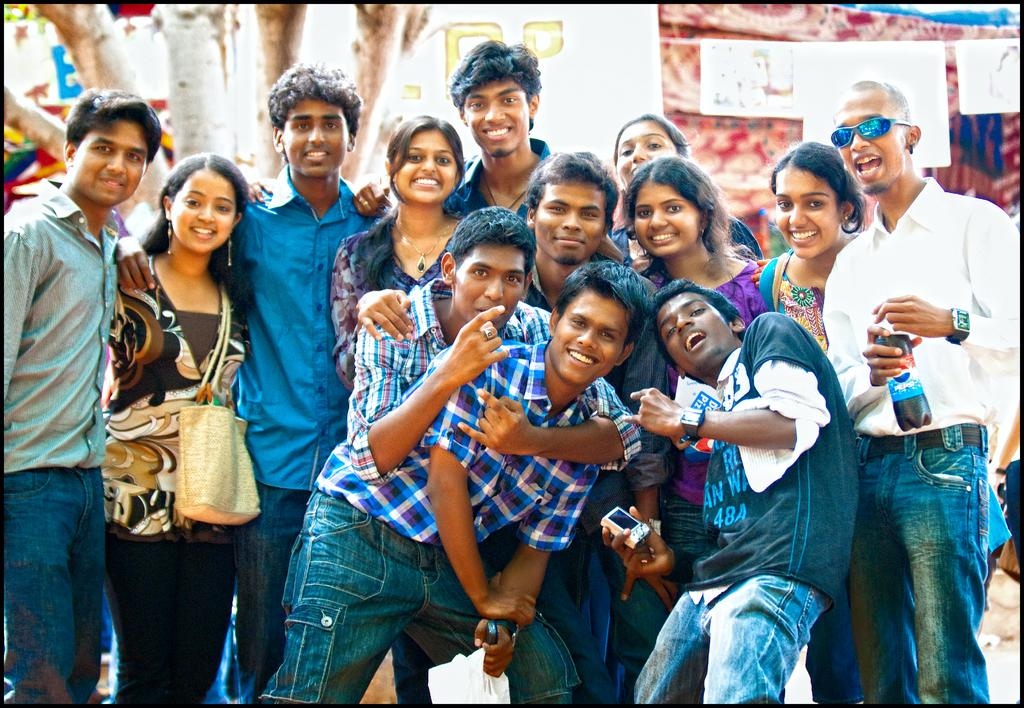How many people are in the image? There is a group of people in the image, but the exact number is not specified. What are the people in the image doing? The people are standing and smiling in the image. What can be seen in the background of the image? There are papers and other objects in the background of the image. What type of hydrant is visible in the image? There is no hydrant present in the image. What drink is being shared among the group of people? There is no drink visible in the image; the people are simply standing and smiling. 